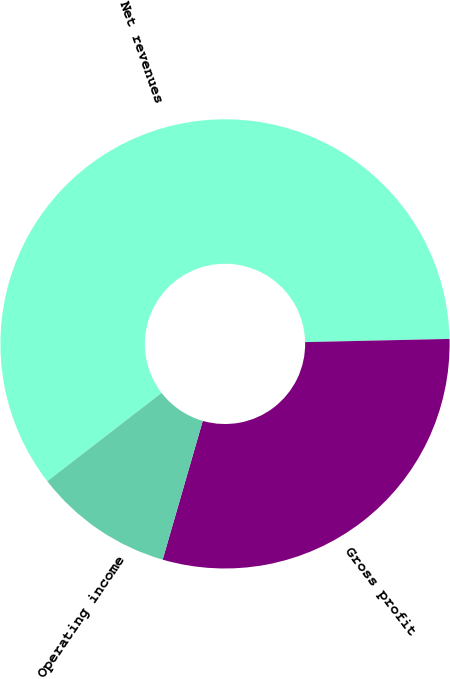Convert chart to OTSL. <chart><loc_0><loc_0><loc_500><loc_500><pie_chart><fcel>Net revenues<fcel>Gross profit<fcel>Operating income<nl><fcel>60.12%<fcel>29.83%<fcel>10.05%<nl></chart> 